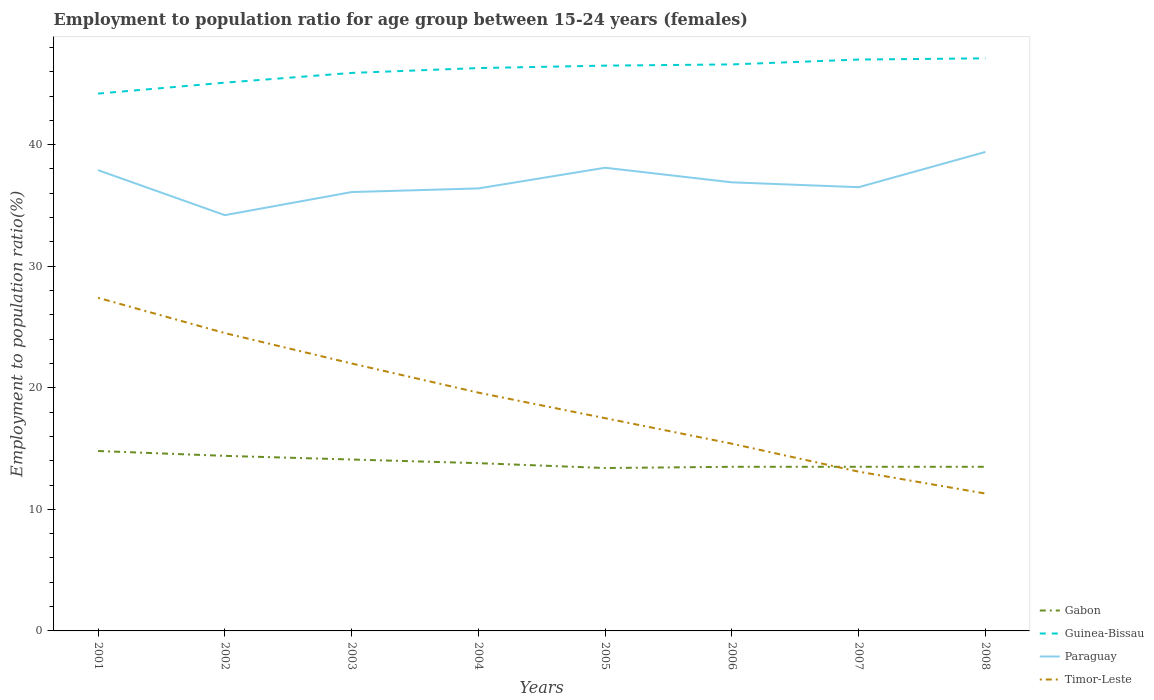Does the line corresponding to Guinea-Bissau intersect with the line corresponding to Timor-Leste?
Provide a succinct answer. No. Is the number of lines equal to the number of legend labels?
Offer a very short reply. Yes. Across all years, what is the maximum employment to population ratio in Timor-Leste?
Your answer should be very brief. 11.3. In which year was the employment to population ratio in Guinea-Bissau maximum?
Give a very brief answer. 2001. What is the total employment to population ratio in Paraguay in the graph?
Your answer should be very brief. -0.3. What is the difference between the highest and the second highest employment to population ratio in Gabon?
Offer a very short reply. 1.4. What is the difference between the highest and the lowest employment to population ratio in Gabon?
Make the answer very short. 3. Is the employment to population ratio in Guinea-Bissau strictly greater than the employment to population ratio in Paraguay over the years?
Your answer should be very brief. No. How many lines are there?
Provide a short and direct response. 4. How many years are there in the graph?
Your answer should be compact. 8. What is the difference between two consecutive major ticks on the Y-axis?
Your answer should be compact. 10. Are the values on the major ticks of Y-axis written in scientific E-notation?
Provide a short and direct response. No. Does the graph contain grids?
Make the answer very short. No. Where does the legend appear in the graph?
Offer a terse response. Bottom right. How many legend labels are there?
Your answer should be compact. 4. How are the legend labels stacked?
Make the answer very short. Vertical. What is the title of the graph?
Give a very brief answer. Employment to population ratio for age group between 15-24 years (females). What is the label or title of the X-axis?
Give a very brief answer. Years. What is the label or title of the Y-axis?
Provide a short and direct response. Employment to population ratio(%). What is the Employment to population ratio(%) in Gabon in 2001?
Your answer should be compact. 14.8. What is the Employment to population ratio(%) in Guinea-Bissau in 2001?
Ensure brevity in your answer.  44.2. What is the Employment to population ratio(%) of Paraguay in 2001?
Offer a very short reply. 37.9. What is the Employment to population ratio(%) in Timor-Leste in 2001?
Keep it short and to the point. 27.4. What is the Employment to population ratio(%) of Gabon in 2002?
Provide a short and direct response. 14.4. What is the Employment to population ratio(%) in Guinea-Bissau in 2002?
Give a very brief answer. 45.1. What is the Employment to population ratio(%) in Paraguay in 2002?
Your response must be concise. 34.2. What is the Employment to population ratio(%) in Timor-Leste in 2002?
Keep it short and to the point. 24.5. What is the Employment to population ratio(%) in Gabon in 2003?
Your answer should be very brief. 14.1. What is the Employment to population ratio(%) in Guinea-Bissau in 2003?
Keep it short and to the point. 45.9. What is the Employment to population ratio(%) of Paraguay in 2003?
Provide a succinct answer. 36.1. What is the Employment to population ratio(%) in Gabon in 2004?
Your answer should be compact. 13.8. What is the Employment to population ratio(%) of Guinea-Bissau in 2004?
Make the answer very short. 46.3. What is the Employment to population ratio(%) of Paraguay in 2004?
Ensure brevity in your answer.  36.4. What is the Employment to population ratio(%) in Timor-Leste in 2004?
Offer a very short reply. 19.6. What is the Employment to population ratio(%) of Gabon in 2005?
Make the answer very short. 13.4. What is the Employment to population ratio(%) in Guinea-Bissau in 2005?
Keep it short and to the point. 46.5. What is the Employment to population ratio(%) in Paraguay in 2005?
Your response must be concise. 38.1. What is the Employment to population ratio(%) of Timor-Leste in 2005?
Offer a terse response. 17.5. What is the Employment to population ratio(%) in Gabon in 2006?
Keep it short and to the point. 13.5. What is the Employment to population ratio(%) in Guinea-Bissau in 2006?
Offer a terse response. 46.6. What is the Employment to population ratio(%) of Paraguay in 2006?
Make the answer very short. 36.9. What is the Employment to population ratio(%) of Timor-Leste in 2006?
Provide a succinct answer. 15.4. What is the Employment to population ratio(%) in Gabon in 2007?
Ensure brevity in your answer.  13.5. What is the Employment to population ratio(%) in Paraguay in 2007?
Give a very brief answer. 36.5. What is the Employment to population ratio(%) of Timor-Leste in 2007?
Provide a succinct answer. 13.1. What is the Employment to population ratio(%) in Guinea-Bissau in 2008?
Offer a terse response. 47.1. What is the Employment to population ratio(%) in Paraguay in 2008?
Give a very brief answer. 39.4. What is the Employment to population ratio(%) in Timor-Leste in 2008?
Your answer should be compact. 11.3. Across all years, what is the maximum Employment to population ratio(%) in Gabon?
Your response must be concise. 14.8. Across all years, what is the maximum Employment to population ratio(%) of Guinea-Bissau?
Make the answer very short. 47.1. Across all years, what is the maximum Employment to population ratio(%) in Paraguay?
Keep it short and to the point. 39.4. Across all years, what is the maximum Employment to population ratio(%) of Timor-Leste?
Ensure brevity in your answer.  27.4. Across all years, what is the minimum Employment to population ratio(%) of Gabon?
Provide a short and direct response. 13.4. Across all years, what is the minimum Employment to population ratio(%) in Guinea-Bissau?
Your response must be concise. 44.2. Across all years, what is the minimum Employment to population ratio(%) in Paraguay?
Your response must be concise. 34.2. Across all years, what is the minimum Employment to population ratio(%) in Timor-Leste?
Offer a terse response. 11.3. What is the total Employment to population ratio(%) in Gabon in the graph?
Keep it short and to the point. 111. What is the total Employment to population ratio(%) of Guinea-Bissau in the graph?
Make the answer very short. 368.7. What is the total Employment to population ratio(%) in Paraguay in the graph?
Keep it short and to the point. 295.5. What is the total Employment to population ratio(%) in Timor-Leste in the graph?
Your response must be concise. 150.8. What is the difference between the Employment to population ratio(%) in Paraguay in 2001 and that in 2002?
Provide a succinct answer. 3.7. What is the difference between the Employment to population ratio(%) in Timor-Leste in 2001 and that in 2002?
Offer a terse response. 2.9. What is the difference between the Employment to population ratio(%) in Guinea-Bissau in 2001 and that in 2003?
Offer a very short reply. -1.7. What is the difference between the Employment to population ratio(%) of Paraguay in 2001 and that in 2003?
Provide a succinct answer. 1.8. What is the difference between the Employment to population ratio(%) in Timor-Leste in 2001 and that in 2004?
Ensure brevity in your answer.  7.8. What is the difference between the Employment to population ratio(%) in Guinea-Bissau in 2001 and that in 2005?
Make the answer very short. -2.3. What is the difference between the Employment to population ratio(%) in Paraguay in 2001 and that in 2005?
Ensure brevity in your answer.  -0.2. What is the difference between the Employment to population ratio(%) of Timor-Leste in 2001 and that in 2005?
Offer a terse response. 9.9. What is the difference between the Employment to population ratio(%) of Gabon in 2001 and that in 2006?
Ensure brevity in your answer.  1.3. What is the difference between the Employment to population ratio(%) in Timor-Leste in 2001 and that in 2006?
Give a very brief answer. 12. What is the difference between the Employment to population ratio(%) of Timor-Leste in 2001 and that in 2007?
Your answer should be very brief. 14.3. What is the difference between the Employment to population ratio(%) of Gabon in 2001 and that in 2008?
Ensure brevity in your answer.  1.3. What is the difference between the Employment to population ratio(%) of Guinea-Bissau in 2001 and that in 2008?
Give a very brief answer. -2.9. What is the difference between the Employment to population ratio(%) in Paraguay in 2001 and that in 2008?
Your answer should be compact. -1.5. What is the difference between the Employment to population ratio(%) of Timor-Leste in 2001 and that in 2008?
Provide a succinct answer. 16.1. What is the difference between the Employment to population ratio(%) of Guinea-Bissau in 2002 and that in 2003?
Your answer should be very brief. -0.8. What is the difference between the Employment to population ratio(%) in Paraguay in 2002 and that in 2003?
Ensure brevity in your answer.  -1.9. What is the difference between the Employment to population ratio(%) of Guinea-Bissau in 2002 and that in 2004?
Offer a terse response. -1.2. What is the difference between the Employment to population ratio(%) of Paraguay in 2002 and that in 2004?
Your answer should be very brief. -2.2. What is the difference between the Employment to population ratio(%) of Timor-Leste in 2002 and that in 2004?
Give a very brief answer. 4.9. What is the difference between the Employment to population ratio(%) in Gabon in 2002 and that in 2005?
Make the answer very short. 1. What is the difference between the Employment to population ratio(%) in Guinea-Bissau in 2002 and that in 2005?
Keep it short and to the point. -1.4. What is the difference between the Employment to population ratio(%) of Paraguay in 2002 and that in 2005?
Offer a very short reply. -3.9. What is the difference between the Employment to population ratio(%) of Timor-Leste in 2002 and that in 2005?
Offer a very short reply. 7. What is the difference between the Employment to population ratio(%) of Gabon in 2002 and that in 2006?
Your answer should be compact. 0.9. What is the difference between the Employment to population ratio(%) of Guinea-Bissau in 2002 and that in 2006?
Your response must be concise. -1.5. What is the difference between the Employment to population ratio(%) in Paraguay in 2002 and that in 2006?
Ensure brevity in your answer.  -2.7. What is the difference between the Employment to population ratio(%) in Timor-Leste in 2002 and that in 2006?
Offer a very short reply. 9.1. What is the difference between the Employment to population ratio(%) in Guinea-Bissau in 2002 and that in 2008?
Your answer should be compact. -2. What is the difference between the Employment to population ratio(%) in Paraguay in 2002 and that in 2008?
Offer a terse response. -5.2. What is the difference between the Employment to population ratio(%) of Timor-Leste in 2002 and that in 2008?
Provide a succinct answer. 13.2. What is the difference between the Employment to population ratio(%) of Gabon in 2003 and that in 2006?
Offer a terse response. 0.6. What is the difference between the Employment to population ratio(%) of Paraguay in 2003 and that in 2006?
Your answer should be compact. -0.8. What is the difference between the Employment to population ratio(%) in Timor-Leste in 2003 and that in 2006?
Your answer should be very brief. 6.6. What is the difference between the Employment to population ratio(%) in Gabon in 2003 and that in 2007?
Your answer should be compact. 0.6. What is the difference between the Employment to population ratio(%) in Paraguay in 2003 and that in 2007?
Give a very brief answer. -0.4. What is the difference between the Employment to population ratio(%) in Timor-Leste in 2003 and that in 2007?
Keep it short and to the point. 8.9. What is the difference between the Employment to population ratio(%) of Gabon in 2003 and that in 2008?
Keep it short and to the point. 0.6. What is the difference between the Employment to population ratio(%) in Guinea-Bissau in 2004 and that in 2005?
Your answer should be compact. -0.2. What is the difference between the Employment to population ratio(%) of Gabon in 2004 and that in 2007?
Offer a very short reply. 0.3. What is the difference between the Employment to population ratio(%) of Paraguay in 2004 and that in 2007?
Give a very brief answer. -0.1. What is the difference between the Employment to population ratio(%) of Timor-Leste in 2004 and that in 2007?
Give a very brief answer. 6.5. What is the difference between the Employment to population ratio(%) in Paraguay in 2004 and that in 2008?
Give a very brief answer. -3. What is the difference between the Employment to population ratio(%) of Timor-Leste in 2004 and that in 2008?
Offer a very short reply. 8.3. What is the difference between the Employment to population ratio(%) of Gabon in 2005 and that in 2006?
Offer a very short reply. -0.1. What is the difference between the Employment to population ratio(%) of Guinea-Bissau in 2005 and that in 2006?
Keep it short and to the point. -0.1. What is the difference between the Employment to population ratio(%) of Guinea-Bissau in 2005 and that in 2007?
Provide a succinct answer. -0.5. What is the difference between the Employment to population ratio(%) in Paraguay in 2005 and that in 2007?
Give a very brief answer. 1.6. What is the difference between the Employment to population ratio(%) in Timor-Leste in 2005 and that in 2007?
Provide a short and direct response. 4.4. What is the difference between the Employment to population ratio(%) in Gabon in 2005 and that in 2008?
Your answer should be compact. -0.1. What is the difference between the Employment to population ratio(%) in Paraguay in 2005 and that in 2008?
Provide a short and direct response. -1.3. What is the difference between the Employment to population ratio(%) in Gabon in 2006 and that in 2007?
Keep it short and to the point. 0. What is the difference between the Employment to population ratio(%) of Gabon in 2006 and that in 2008?
Your response must be concise. 0. What is the difference between the Employment to population ratio(%) in Guinea-Bissau in 2006 and that in 2008?
Give a very brief answer. -0.5. What is the difference between the Employment to population ratio(%) of Timor-Leste in 2006 and that in 2008?
Your answer should be compact. 4.1. What is the difference between the Employment to population ratio(%) in Paraguay in 2007 and that in 2008?
Provide a succinct answer. -2.9. What is the difference between the Employment to population ratio(%) of Timor-Leste in 2007 and that in 2008?
Keep it short and to the point. 1.8. What is the difference between the Employment to population ratio(%) in Gabon in 2001 and the Employment to population ratio(%) in Guinea-Bissau in 2002?
Give a very brief answer. -30.3. What is the difference between the Employment to population ratio(%) in Gabon in 2001 and the Employment to population ratio(%) in Paraguay in 2002?
Give a very brief answer. -19.4. What is the difference between the Employment to population ratio(%) in Guinea-Bissau in 2001 and the Employment to population ratio(%) in Paraguay in 2002?
Ensure brevity in your answer.  10. What is the difference between the Employment to population ratio(%) in Gabon in 2001 and the Employment to population ratio(%) in Guinea-Bissau in 2003?
Provide a succinct answer. -31.1. What is the difference between the Employment to population ratio(%) of Gabon in 2001 and the Employment to population ratio(%) of Paraguay in 2003?
Your answer should be very brief. -21.3. What is the difference between the Employment to population ratio(%) of Gabon in 2001 and the Employment to population ratio(%) of Timor-Leste in 2003?
Your answer should be compact. -7.2. What is the difference between the Employment to population ratio(%) in Guinea-Bissau in 2001 and the Employment to population ratio(%) in Paraguay in 2003?
Make the answer very short. 8.1. What is the difference between the Employment to population ratio(%) of Gabon in 2001 and the Employment to population ratio(%) of Guinea-Bissau in 2004?
Offer a terse response. -31.5. What is the difference between the Employment to population ratio(%) of Gabon in 2001 and the Employment to population ratio(%) of Paraguay in 2004?
Your response must be concise. -21.6. What is the difference between the Employment to population ratio(%) of Guinea-Bissau in 2001 and the Employment to population ratio(%) of Paraguay in 2004?
Give a very brief answer. 7.8. What is the difference between the Employment to population ratio(%) in Guinea-Bissau in 2001 and the Employment to population ratio(%) in Timor-Leste in 2004?
Make the answer very short. 24.6. What is the difference between the Employment to population ratio(%) of Paraguay in 2001 and the Employment to population ratio(%) of Timor-Leste in 2004?
Your answer should be compact. 18.3. What is the difference between the Employment to population ratio(%) of Gabon in 2001 and the Employment to population ratio(%) of Guinea-Bissau in 2005?
Offer a very short reply. -31.7. What is the difference between the Employment to population ratio(%) of Gabon in 2001 and the Employment to population ratio(%) of Paraguay in 2005?
Offer a very short reply. -23.3. What is the difference between the Employment to population ratio(%) in Guinea-Bissau in 2001 and the Employment to population ratio(%) in Timor-Leste in 2005?
Make the answer very short. 26.7. What is the difference between the Employment to population ratio(%) in Paraguay in 2001 and the Employment to population ratio(%) in Timor-Leste in 2005?
Ensure brevity in your answer.  20.4. What is the difference between the Employment to population ratio(%) of Gabon in 2001 and the Employment to population ratio(%) of Guinea-Bissau in 2006?
Give a very brief answer. -31.8. What is the difference between the Employment to population ratio(%) of Gabon in 2001 and the Employment to population ratio(%) of Paraguay in 2006?
Your answer should be compact. -22.1. What is the difference between the Employment to population ratio(%) of Guinea-Bissau in 2001 and the Employment to population ratio(%) of Timor-Leste in 2006?
Provide a succinct answer. 28.8. What is the difference between the Employment to population ratio(%) in Gabon in 2001 and the Employment to population ratio(%) in Guinea-Bissau in 2007?
Make the answer very short. -32.2. What is the difference between the Employment to population ratio(%) in Gabon in 2001 and the Employment to population ratio(%) in Paraguay in 2007?
Your answer should be compact. -21.7. What is the difference between the Employment to population ratio(%) in Guinea-Bissau in 2001 and the Employment to population ratio(%) in Paraguay in 2007?
Your answer should be very brief. 7.7. What is the difference between the Employment to population ratio(%) in Guinea-Bissau in 2001 and the Employment to population ratio(%) in Timor-Leste in 2007?
Provide a short and direct response. 31.1. What is the difference between the Employment to population ratio(%) in Paraguay in 2001 and the Employment to population ratio(%) in Timor-Leste in 2007?
Offer a very short reply. 24.8. What is the difference between the Employment to population ratio(%) in Gabon in 2001 and the Employment to population ratio(%) in Guinea-Bissau in 2008?
Provide a succinct answer. -32.3. What is the difference between the Employment to population ratio(%) of Gabon in 2001 and the Employment to population ratio(%) of Paraguay in 2008?
Keep it short and to the point. -24.6. What is the difference between the Employment to population ratio(%) of Gabon in 2001 and the Employment to population ratio(%) of Timor-Leste in 2008?
Provide a short and direct response. 3.5. What is the difference between the Employment to population ratio(%) in Guinea-Bissau in 2001 and the Employment to population ratio(%) in Timor-Leste in 2008?
Offer a very short reply. 32.9. What is the difference between the Employment to population ratio(%) in Paraguay in 2001 and the Employment to population ratio(%) in Timor-Leste in 2008?
Ensure brevity in your answer.  26.6. What is the difference between the Employment to population ratio(%) of Gabon in 2002 and the Employment to population ratio(%) of Guinea-Bissau in 2003?
Give a very brief answer. -31.5. What is the difference between the Employment to population ratio(%) of Gabon in 2002 and the Employment to population ratio(%) of Paraguay in 2003?
Keep it short and to the point. -21.7. What is the difference between the Employment to population ratio(%) in Guinea-Bissau in 2002 and the Employment to population ratio(%) in Paraguay in 2003?
Provide a succinct answer. 9. What is the difference between the Employment to population ratio(%) in Guinea-Bissau in 2002 and the Employment to population ratio(%) in Timor-Leste in 2003?
Your response must be concise. 23.1. What is the difference between the Employment to population ratio(%) in Gabon in 2002 and the Employment to population ratio(%) in Guinea-Bissau in 2004?
Offer a very short reply. -31.9. What is the difference between the Employment to population ratio(%) in Gabon in 2002 and the Employment to population ratio(%) in Paraguay in 2004?
Give a very brief answer. -22. What is the difference between the Employment to population ratio(%) in Guinea-Bissau in 2002 and the Employment to population ratio(%) in Paraguay in 2004?
Offer a terse response. 8.7. What is the difference between the Employment to population ratio(%) of Gabon in 2002 and the Employment to population ratio(%) of Guinea-Bissau in 2005?
Offer a very short reply. -32.1. What is the difference between the Employment to population ratio(%) of Gabon in 2002 and the Employment to population ratio(%) of Paraguay in 2005?
Give a very brief answer. -23.7. What is the difference between the Employment to population ratio(%) in Gabon in 2002 and the Employment to population ratio(%) in Timor-Leste in 2005?
Keep it short and to the point. -3.1. What is the difference between the Employment to population ratio(%) in Guinea-Bissau in 2002 and the Employment to population ratio(%) in Timor-Leste in 2005?
Give a very brief answer. 27.6. What is the difference between the Employment to population ratio(%) of Paraguay in 2002 and the Employment to population ratio(%) of Timor-Leste in 2005?
Your answer should be very brief. 16.7. What is the difference between the Employment to population ratio(%) of Gabon in 2002 and the Employment to population ratio(%) of Guinea-Bissau in 2006?
Provide a short and direct response. -32.2. What is the difference between the Employment to population ratio(%) in Gabon in 2002 and the Employment to population ratio(%) in Paraguay in 2006?
Provide a succinct answer. -22.5. What is the difference between the Employment to population ratio(%) of Gabon in 2002 and the Employment to population ratio(%) of Timor-Leste in 2006?
Provide a succinct answer. -1. What is the difference between the Employment to population ratio(%) of Guinea-Bissau in 2002 and the Employment to population ratio(%) of Timor-Leste in 2006?
Your response must be concise. 29.7. What is the difference between the Employment to population ratio(%) in Gabon in 2002 and the Employment to population ratio(%) in Guinea-Bissau in 2007?
Keep it short and to the point. -32.6. What is the difference between the Employment to population ratio(%) of Gabon in 2002 and the Employment to population ratio(%) of Paraguay in 2007?
Provide a short and direct response. -22.1. What is the difference between the Employment to population ratio(%) of Paraguay in 2002 and the Employment to population ratio(%) of Timor-Leste in 2007?
Offer a terse response. 21.1. What is the difference between the Employment to population ratio(%) of Gabon in 2002 and the Employment to population ratio(%) of Guinea-Bissau in 2008?
Ensure brevity in your answer.  -32.7. What is the difference between the Employment to population ratio(%) of Gabon in 2002 and the Employment to population ratio(%) of Paraguay in 2008?
Offer a very short reply. -25. What is the difference between the Employment to population ratio(%) in Gabon in 2002 and the Employment to population ratio(%) in Timor-Leste in 2008?
Ensure brevity in your answer.  3.1. What is the difference between the Employment to population ratio(%) of Guinea-Bissau in 2002 and the Employment to population ratio(%) of Timor-Leste in 2008?
Keep it short and to the point. 33.8. What is the difference between the Employment to population ratio(%) in Paraguay in 2002 and the Employment to population ratio(%) in Timor-Leste in 2008?
Provide a short and direct response. 22.9. What is the difference between the Employment to population ratio(%) in Gabon in 2003 and the Employment to population ratio(%) in Guinea-Bissau in 2004?
Provide a short and direct response. -32.2. What is the difference between the Employment to population ratio(%) in Gabon in 2003 and the Employment to population ratio(%) in Paraguay in 2004?
Offer a terse response. -22.3. What is the difference between the Employment to population ratio(%) in Gabon in 2003 and the Employment to population ratio(%) in Timor-Leste in 2004?
Ensure brevity in your answer.  -5.5. What is the difference between the Employment to population ratio(%) in Guinea-Bissau in 2003 and the Employment to population ratio(%) in Timor-Leste in 2004?
Your response must be concise. 26.3. What is the difference between the Employment to population ratio(%) in Gabon in 2003 and the Employment to population ratio(%) in Guinea-Bissau in 2005?
Ensure brevity in your answer.  -32.4. What is the difference between the Employment to population ratio(%) of Gabon in 2003 and the Employment to population ratio(%) of Paraguay in 2005?
Provide a succinct answer. -24. What is the difference between the Employment to population ratio(%) of Gabon in 2003 and the Employment to population ratio(%) of Timor-Leste in 2005?
Offer a very short reply. -3.4. What is the difference between the Employment to population ratio(%) in Guinea-Bissau in 2003 and the Employment to population ratio(%) in Timor-Leste in 2005?
Provide a short and direct response. 28.4. What is the difference between the Employment to population ratio(%) of Gabon in 2003 and the Employment to population ratio(%) of Guinea-Bissau in 2006?
Your response must be concise. -32.5. What is the difference between the Employment to population ratio(%) in Gabon in 2003 and the Employment to population ratio(%) in Paraguay in 2006?
Keep it short and to the point. -22.8. What is the difference between the Employment to population ratio(%) of Guinea-Bissau in 2003 and the Employment to population ratio(%) of Paraguay in 2006?
Make the answer very short. 9. What is the difference between the Employment to population ratio(%) of Guinea-Bissau in 2003 and the Employment to population ratio(%) of Timor-Leste in 2006?
Ensure brevity in your answer.  30.5. What is the difference between the Employment to population ratio(%) in Paraguay in 2003 and the Employment to population ratio(%) in Timor-Leste in 2006?
Your response must be concise. 20.7. What is the difference between the Employment to population ratio(%) in Gabon in 2003 and the Employment to population ratio(%) in Guinea-Bissau in 2007?
Make the answer very short. -32.9. What is the difference between the Employment to population ratio(%) in Gabon in 2003 and the Employment to population ratio(%) in Paraguay in 2007?
Give a very brief answer. -22.4. What is the difference between the Employment to population ratio(%) of Guinea-Bissau in 2003 and the Employment to population ratio(%) of Timor-Leste in 2007?
Provide a succinct answer. 32.8. What is the difference between the Employment to population ratio(%) of Gabon in 2003 and the Employment to population ratio(%) of Guinea-Bissau in 2008?
Ensure brevity in your answer.  -33. What is the difference between the Employment to population ratio(%) in Gabon in 2003 and the Employment to population ratio(%) in Paraguay in 2008?
Your response must be concise. -25.3. What is the difference between the Employment to population ratio(%) of Guinea-Bissau in 2003 and the Employment to population ratio(%) of Paraguay in 2008?
Offer a terse response. 6.5. What is the difference between the Employment to population ratio(%) of Guinea-Bissau in 2003 and the Employment to population ratio(%) of Timor-Leste in 2008?
Offer a very short reply. 34.6. What is the difference between the Employment to population ratio(%) of Paraguay in 2003 and the Employment to population ratio(%) of Timor-Leste in 2008?
Offer a very short reply. 24.8. What is the difference between the Employment to population ratio(%) in Gabon in 2004 and the Employment to population ratio(%) in Guinea-Bissau in 2005?
Your response must be concise. -32.7. What is the difference between the Employment to population ratio(%) of Gabon in 2004 and the Employment to population ratio(%) of Paraguay in 2005?
Offer a very short reply. -24.3. What is the difference between the Employment to population ratio(%) in Guinea-Bissau in 2004 and the Employment to population ratio(%) in Timor-Leste in 2005?
Give a very brief answer. 28.8. What is the difference between the Employment to population ratio(%) of Gabon in 2004 and the Employment to population ratio(%) of Guinea-Bissau in 2006?
Provide a succinct answer. -32.8. What is the difference between the Employment to population ratio(%) of Gabon in 2004 and the Employment to population ratio(%) of Paraguay in 2006?
Ensure brevity in your answer.  -23.1. What is the difference between the Employment to population ratio(%) in Gabon in 2004 and the Employment to population ratio(%) in Timor-Leste in 2006?
Your answer should be compact. -1.6. What is the difference between the Employment to population ratio(%) of Guinea-Bissau in 2004 and the Employment to population ratio(%) of Paraguay in 2006?
Your answer should be very brief. 9.4. What is the difference between the Employment to population ratio(%) of Guinea-Bissau in 2004 and the Employment to population ratio(%) of Timor-Leste in 2006?
Provide a short and direct response. 30.9. What is the difference between the Employment to population ratio(%) of Paraguay in 2004 and the Employment to population ratio(%) of Timor-Leste in 2006?
Your answer should be compact. 21. What is the difference between the Employment to population ratio(%) in Gabon in 2004 and the Employment to population ratio(%) in Guinea-Bissau in 2007?
Keep it short and to the point. -33.2. What is the difference between the Employment to population ratio(%) in Gabon in 2004 and the Employment to population ratio(%) in Paraguay in 2007?
Offer a terse response. -22.7. What is the difference between the Employment to population ratio(%) of Guinea-Bissau in 2004 and the Employment to population ratio(%) of Timor-Leste in 2007?
Offer a very short reply. 33.2. What is the difference between the Employment to population ratio(%) in Paraguay in 2004 and the Employment to population ratio(%) in Timor-Leste in 2007?
Offer a very short reply. 23.3. What is the difference between the Employment to population ratio(%) of Gabon in 2004 and the Employment to population ratio(%) of Guinea-Bissau in 2008?
Your answer should be very brief. -33.3. What is the difference between the Employment to population ratio(%) in Gabon in 2004 and the Employment to population ratio(%) in Paraguay in 2008?
Offer a very short reply. -25.6. What is the difference between the Employment to population ratio(%) in Guinea-Bissau in 2004 and the Employment to population ratio(%) in Paraguay in 2008?
Provide a short and direct response. 6.9. What is the difference between the Employment to population ratio(%) of Guinea-Bissau in 2004 and the Employment to population ratio(%) of Timor-Leste in 2008?
Give a very brief answer. 35. What is the difference between the Employment to population ratio(%) of Paraguay in 2004 and the Employment to population ratio(%) of Timor-Leste in 2008?
Give a very brief answer. 25.1. What is the difference between the Employment to population ratio(%) in Gabon in 2005 and the Employment to population ratio(%) in Guinea-Bissau in 2006?
Ensure brevity in your answer.  -33.2. What is the difference between the Employment to population ratio(%) of Gabon in 2005 and the Employment to population ratio(%) of Paraguay in 2006?
Give a very brief answer. -23.5. What is the difference between the Employment to population ratio(%) in Gabon in 2005 and the Employment to population ratio(%) in Timor-Leste in 2006?
Keep it short and to the point. -2. What is the difference between the Employment to population ratio(%) in Guinea-Bissau in 2005 and the Employment to population ratio(%) in Timor-Leste in 2006?
Offer a very short reply. 31.1. What is the difference between the Employment to population ratio(%) of Paraguay in 2005 and the Employment to population ratio(%) of Timor-Leste in 2006?
Offer a terse response. 22.7. What is the difference between the Employment to population ratio(%) of Gabon in 2005 and the Employment to population ratio(%) of Guinea-Bissau in 2007?
Ensure brevity in your answer.  -33.6. What is the difference between the Employment to population ratio(%) of Gabon in 2005 and the Employment to population ratio(%) of Paraguay in 2007?
Give a very brief answer. -23.1. What is the difference between the Employment to population ratio(%) in Gabon in 2005 and the Employment to population ratio(%) in Timor-Leste in 2007?
Offer a terse response. 0.3. What is the difference between the Employment to population ratio(%) of Guinea-Bissau in 2005 and the Employment to population ratio(%) of Timor-Leste in 2007?
Offer a terse response. 33.4. What is the difference between the Employment to population ratio(%) of Gabon in 2005 and the Employment to population ratio(%) of Guinea-Bissau in 2008?
Keep it short and to the point. -33.7. What is the difference between the Employment to population ratio(%) of Gabon in 2005 and the Employment to population ratio(%) of Paraguay in 2008?
Ensure brevity in your answer.  -26. What is the difference between the Employment to population ratio(%) in Gabon in 2005 and the Employment to population ratio(%) in Timor-Leste in 2008?
Provide a short and direct response. 2.1. What is the difference between the Employment to population ratio(%) in Guinea-Bissau in 2005 and the Employment to population ratio(%) in Timor-Leste in 2008?
Your response must be concise. 35.2. What is the difference between the Employment to population ratio(%) of Paraguay in 2005 and the Employment to population ratio(%) of Timor-Leste in 2008?
Give a very brief answer. 26.8. What is the difference between the Employment to population ratio(%) of Gabon in 2006 and the Employment to population ratio(%) of Guinea-Bissau in 2007?
Your answer should be compact. -33.5. What is the difference between the Employment to population ratio(%) in Gabon in 2006 and the Employment to population ratio(%) in Paraguay in 2007?
Provide a short and direct response. -23. What is the difference between the Employment to population ratio(%) of Gabon in 2006 and the Employment to population ratio(%) of Timor-Leste in 2007?
Your answer should be compact. 0.4. What is the difference between the Employment to population ratio(%) in Guinea-Bissau in 2006 and the Employment to population ratio(%) in Timor-Leste in 2007?
Offer a terse response. 33.5. What is the difference between the Employment to population ratio(%) of Paraguay in 2006 and the Employment to population ratio(%) of Timor-Leste in 2007?
Give a very brief answer. 23.8. What is the difference between the Employment to population ratio(%) of Gabon in 2006 and the Employment to population ratio(%) of Guinea-Bissau in 2008?
Give a very brief answer. -33.6. What is the difference between the Employment to population ratio(%) in Gabon in 2006 and the Employment to population ratio(%) in Paraguay in 2008?
Make the answer very short. -25.9. What is the difference between the Employment to population ratio(%) of Gabon in 2006 and the Employment to population ratio(%) of Timor-Leste in 2008?
Your answer should be very brief. 2.2. What is the difference between the Employment to population ratio(%) in Guinea-Bissau in 2006 and the Employment to population ratio(%) in Timor-Leste in 2008?
Your answer should be compact. 35.3. What is the difference between the Employment to population ratio(%) of Paraguay in 2006 and the Employment to population ratio(%) of Timor-Leste in 2008?
Provide a succinct answer. 25.6. What is the difference between the Employment to population ratio(%) in Gabon in 2007 and the Employment to population ratio(%) in Guinea-Bissau in 2008?
Your answer should be very brief. -33.6. What is the difference between the Employment to population ratio(%) of Gabon in 2007 and the Employment to population ratio(%) of Paraguay in 2008?
Your response must be concise. -25.9. What is the difference between the Employment to population ratio(%) in Gabon in 2007 and the Employment to population ratio(%) in Timor-Leste in 2008?
Give a very brief answer. 2.2. What is the difference between the Employment to population ratio(%) of Guinea-Bissau in 2007 and the Employment to population ratio(%) of Timor-Leste in 2008?
Keep it short and to the point. 35.7. What is the difference between the Employment to population ratio(%) of Paraguay in 2007 and the Employment to population ratio(%) of Timor-Leste in 2008?
Keep it short and to the point. 25.2. What is the average Employment to population ratio(%) in Gabon per year?
Your response must be concise. 13.88. What is the average Employment to population ratio(%) of Guinea-Bissau per year?
Provide a succinct answer. 46.09. What is the average Employment to population ratio(%) in Paraguay per year?
Your answer should be very brief. 36.94. What is the average Employment to population ratio(%) of Timor-Leste per year?
Provide a short and direct response. 18.85. In the year 2001, what is the difference between the Employment to population ratio(%) of Gabon and Employment to population ratio(%) of Guinea-Bissau?
Provide a short and direct response. -29.4. In the year 2001, what is the difference between the Employment to population ratio(%) of Gabon and Employment to population ratio(%) of Paraguay?
Your answer should be very brief. -23.1. In the year 2001, what is the difference between the Employment to population ratio(%) in Paraguay and Employment to population ratio(%) in Timor-Leste?
Offer a very short reply. 10.5. In the year 2002, what is the difference between the Employment to population ratio(%) in Gabon and Employment to population ratio(%) in Guinea-Bissau?
Ensure brevity in your answer.  -30.7. In the year 2002, what is the difference between the Employment to population ratio(%) in Gabon and Employment to population ratio(%) in Paraguay?
Offer a very short reply. -19.8. In the year 2002, what is the difference between the Employment to population ratio(%) of Guinea-Bissau and Employment to population ratio(%) of Paraguay?
Offer a terse response. 10.9. In the year 2002, what is the difference between the Employment to population ratio(%) of Guinea-Bissau and Employment to population ratio(%) of Timor-Leste?
Give a very brief answer. 20.6. In the year 2002, what is the difference between the Employment to population ratio(%) in Paraguay and Employment to population ratio(%) in Timor-Leste?
Your response must be concise. 9.7. In the year 2003, what is the difference between the Employment to population ratio(%) of Gabon and Employment to population ratio(%) of Guinea-Bissau?
Ensure brevity in your answer.  -31.8. In the year 2003, what is the difference between the Employment to population ratio(%) in Gabon and Employment to population ratio(%) in Timor-Leste?
Offer a very short reply. -7.9. In the year 2003, what is the difference between the Employment to population ratio(%) of Guinea-Bissau and Employment to population ratio(%) of Paraguay?
Offer a very short reply. 9.8. In the year 2003, what is the difference between the Employment to population ratio(%) of Guinea-Bissau and Employment to population ratio(%) of Timor-Leste?
Provide a succinct answer. 23.9. In the year 2003, what is the difference between the Employment to population ratio(%) in Paraguay and Employment to population ratio(%) in Timor-Leste?
Your answer should be compact. 14.1. In the year 2004, what is the difference between the Employment to population ratio(%) of Gabon and Employment to population ratio(%) of Guinea-Bissau?
Offer a very short reply. -32.5. In the year 2004, what is the difference between the Employment to population ratio(%) of Gabon and Employment to population ratio(%) of Paraguay?
Give a very brief answer. -22.6. In the year 2004, what is the difference between the Employment to population ratio(%) in Gabon and Employment to population ratio(%) in Timor-Leste?
Make the answer very short. -5.8. In the year 2004, what is the difference between the Employment to population ratio(%) of Guinea-Bissau and Employment to population ratio(%) of Timor-Leste?
Keep it short and to the point. 26.7. In the year 2004, what is the difference between the Employment to population ratio(%) in Paraguay and Employment to population ratio(%) in Timor-Leste?
Provide a succinct answer. 16.8. In the year 2005, what is the difference between the Employment to population ratio(%) of Gabon and Employment to population ratio(%) of Guinea-Bissau?
Make the answer very short. -33.1. In the year 2005, what is the difference between the Employment to population ratio(%) of Gabon and Employment to population ratio(%) of Paraguay?
Give a very brief answer. -24.7. In the year 2005, what is the difference between the Employment to population ratio(%) in Paraguay and Employment to population ratio(%) in Timor-Leste?
Keep it short and to the point. 20.6. In the year 2006, what is the difference between the Employment to population ratio(%) in Gabon and Employment to population ratio(%) in Guinea-Bissau?
Make the answer very short. -33.1. In the year 2006, what is the difference between the Employment to population ratio(%) in Gabon and Employment to population ratio(%) in Paraguay?
Your response must be concise. -23.4. In the year 2006, what is the difference between the Employment to population ratio(%) in Gabon and Employment to population ratio(%) in Timor-Leste?
Your answer should be very brief. -1.9. In the year 2006, what is the difference between the Employment to population ratio(%) in Guinea-Bissau and Employment to population ratio(%) in Paraguay?
Your response must be concise. 9.7. In the year 2006, what is the difference between the Employment to population ratio(%) of Guinea-Bissau and Employment to population ratio(%) of Timor-Leste?
Offer a very short reply. 31.2. In the year 2006, what is the difference between the Employment to population ratio(%) in Paraguay and Employment to population ratio(%) in Timor-Leste?
Give a very brief answer. 21.5. In the year 2007, what is the difference between the Employment to population ratio(%) of Gabon and Employment to population ratio(%) of Guinea-Bissau?
Make the answer very short. -33.5. In the year 2007, what is the difference between the Employment to population ratio(%) in Gabon and Employment to population ratio(%) in Paraguay?
Your response must be concise. -23. In the year 2007, what is the difference between the Employment to population ratio(%) of Gabon and Employment to population ratio(%) of Timor-Leste?
Your response must be concise. 0.4. In the year 2007, what is the difference between the Employment to population ratio(%) of Guinea-Bissau and Employment to population ratio(%) of Paraguay?
Offer a very short reply. 10.5. In the year 2007, what is the difference between the Employment to population ratio(%) in Guinea-Bissau and Employment to population ratio(%) in Timor-Leste?
Your response must be concise. 33.9. In the year 2007, what is the difference between the Employment to population ratio(%) of Paraguay and Employment to population ratio(%) of Timor-Leste?
Offer a very short reply. 23.4. In the year 2008, what is the difference between the Employment to population ratio(%) in Gabon and Employment to population ratio(%) in Guinea-Bissau?
Your answer should be compact. -33.6. In the year 2008, what is the difference between the Employment to population ratio(%) of Gabon and Employment to population ratio(%) of Paraguay?
Provide a succinct answer. -25.9. In the year 2008, what is the difference between the Employment to population ratio(%) of Guinea-Bissau and Employment to population ratio(%) of Timor-Leste?
Give a very brief answer. 35.8. In the year 2008, what is the difference between the Employment to population ratio(%) in Paraguay and Employment to population ratio(%) in Timor-Leste?
Give a very brief answer. 28.1. What is the ratio of the Employment to population ratio(%) in Gabon in 2001 to that in 2002?
Your response must be concise. 1.03. What is the ratio of the Employment to population ratio(%) of Guinea-Bissau in 2001 to that in 2002?
Ensure brevity in your answer.  0.98. What is the ratio of the Employment to population ratio(%) in Paraguay in 2001 to that in 2002?
Ensure brevity in your answer.  1.11. What is the ratio of the Employment to population ratio(%) in Timor-Leste in 2001 to that in 2002?
Offer a terse response. 1.12. What is the ratio of the Employment to population ratio(%) of Gabon in 2001 to that in 2003?
Your answer should be very brief. 1.05. What is the ratio of the Employment to population ratio(%) of Paraguay in 2001 to that in 2003?
Offer a terse response. 1.05. What is the ratio of the Employment to population ratio(%) in Timor-Leste in 2001 to that in 2003?
Give a very brief answer. 1.25. What is the ratio of the Employment to population ratio(%) in Gabon in 2001 to that in 2004?
Your answer should be compact. 1.07. What is the ratio of the Employment to population ratio(%) of Guinea-Bissau in 2001 to that in 2004?
Offer a terse response. 0.95. What is the ratio of the Employment to population ratio(%) in Paraguay in 2001 to that in 2004?
Your answer should be compact. 1.04. What is the ratio of the Employment to population ratio(%) of Timor-Leste in 2001 to that in 2004?
Give a very brief answer. 1.4. What is the ratio of the Employment to population ratio(%) in Gabon in 2001 to that in 2005?
Provide a succinct answer. 1.1. What is the ratio of the Employment to population ratio(%) of Guinea-Bissau in 2001 to that in 2005?
Offer a very short reply. 0.95. What is the ratio of the Employment to population ratio(%) in Paraguay in 2001 to that in 2005?
Provide a short and direct response. 0.99. What is the ratio of the Employment to population ratio(%) in Timor-Leste in 2001 to that in 2005?
Provide a short and direct response. 1.57. What is the ratio of the Employment to population ratio(%) of Gabon in 2001 to that in 2006?
Keep it short and to the point. 1.1. What is the ratio of the Employment to population ratio(%) in Guinea-Bissau in 2001 to that in 2006?
Your answer should be compact. 0.95. What is the ratio of the Employment to population ratio(%) in Paraguay in 2001 to that in 2006?
Ensure brevity in your answer.  1.03. What is the ratio of the Employment to population ratio(%) in Timor-Leste in 2001 to that in 2006?
Your response must be concise. 1.78. What is the ratio of the Employment to population ratio(%) of Gabon in 2001 to that in 2007?
Your response must be concise. 1.1. What is the ratio of the Employment to population ratio(%) in Guinea-Bissau in 2001 to that in 2007?
Keep it short and to the point. 0.94. What is the ratio of the Employment to population ratio(%) of Paraguay in 2001 to that in 2007?
Provide a succinct answer. 1.04. What is the ratio of the Employment to population ratio(%) in Timor-Leste in 2001 to that in 2007?
Provide a succinct answer. 2.09. What is the ratio of the Employment to population ratio(%) of Gabon in 2001 to that in 2008?
Provide a succinct answer. 1.1. What is the ratio of the Employment to population ratio(%) of Guinea-Bissau in 2001 to that in 2008?
Your answer should be very brief. 0.94. What is the ratio of the Employment to population ratio(%) in Paraguay in 2001 to that in 2008?
Offer a very short reply. 0.96. What is the ratio of the Employment to population ratio(%) in Timor-Leste in 2001 to that in 2008?
Provide a succinct answer. 2.42. What is the ratio of the Employment to population ratio(%) in Gabon in 2002 to that in 2003?
Give a very brief answer. 1.02. What is the ratio of the Employment to population ratio(%) in Guinea-Bissau in 2002 to that in 2003?
Your response must be concise. 0.98. What is the ratio of the Employment to population ratio(%) of Timor-Leste in 2002 to that in 2003?
Give a very brief answer. 1.11. What is the ratio of the Employment to population ratio(%) in Gabon in 2002 to that in 2004?
Keep it short and to the point. 1.04. What is the ratio of the Employment to population ratio(%) in Guinea-Bissau in 2002 to that in 2004?
Your answer should be very brief. 0.97. What is the ratio of the Employment to population ratio(%) in Paraguay in 2002 to that in 2004?
Provide a short and direct response. 0.94. What is the ratio of the Employment to population ratio(%) of Gabon in 2002 to that in 2005?
Your answer should be very brief. 1.07. What is the ratio of the Employment to population ratio(%) of Guinea-Bissau in 2002 to that in 2005?
Offer a very short reply. 0.97. What is the ratio of the Employment to population ratio(%) of Paraguay in 2002 to that in 2005?
Keep it short and to the point. 0.9. What is the ratio of the Employment to population ratio(%) in Timor-Leste in 2002 to that in 2005?
Give a very brief answer. 1.4. What is the ratio of the Employment to population ratio(%) of Gabon in 2002 to that in 2006?
Your answer should be compact. 1.07. What is the ratio of the Employment to population ratio(%) in Guinea-Bissau in 2002 to that in 2006?
Your answer should be compact. 0.97. What is the ratio of the Employment to population ratio(%) in Paraguay in 2002 to that in 2006?
Give a very brief answer. 0.93. What is the ratio of the Employment to population ratio(%) in Timor-Leste in 2002 to that in 2006?
Keep it short and to the point. 1.59. What is the ratio of the Employment to population ratio(%) in Gabon in 2002 to that in 2007?
Keep it short and to the point. 1.07. What is the ratio of the Employment to population ratio(%) in Guinea-Bissau in 2002 to that in 2007?
Your response must be concise. 0.96. What is the ratio of the Employment to population ratio(%) in Paraguay in 2002 to that in 2007?
Offer a terse response. 0.94. What is the ratio of the Employment to population ratio(%) of Timor-Leste in 2002 to that in 2007?
Your answer should be compact. 1.87. What is the ratio of the Employment to population ratio(%) of Gabon in 2002 to that in 2008?
Give a very brief answer. 1.07. What is the ratio of the Employment to population ratio(%) in Guinea-Bissau in 2002 to that in 2008?
Your response must be concise. 0.96. What is the ratio of the Employment to population ratio(%) of Paraguay in 2002 to that in 2008?
Give a very brief answer. 0.87. What is the ratio of the Employment to population ratio(%) in Timor-Leste in 2002 to that in 2008?
Keep it short and to the point. 2.17. What is the ratio of the Employment to population ratio(%) of Gabon in 2003 to that in 2004?
Offer a very short reply. 1.02. What is the ratio of the Employment to population ratio(%) of Guinea-Bissau in 2003 to that in 2004?
Ensure brevity in your answer.  0.99. What is the ratio of the Employment to population ratio(%) of Paraguay in 2003 to that in 2004?
Your answer should be very brief. 0.99. What is the ratio of the Employment to population ratio(%) of Timor-Leste in 2003 to that in 2004?
Offer a terse response. 1.12. What is the ratio of the Employment to population ratio(%) of Gabon in 2003 to that in 2005?
Your response must be concise. 1.05. What is the ratio of the Employment to population ratio(%) of Guinea-Bissau in 2003 to that in 2005?
Offer a very short reply. 0.99. What is the ratio of the Employment to population ratio(%) of Paraguay in 2003 to that in 2005?
Ensure brevity in your answer.  0.95. What is the ratio of the Employment to population ratio(%) of Timor-Leste in 2003 to that in 2005?
Offer a terse response. 1.26. What is the ratio of the Employment to population ratio(%) of Gabon in 2003 to that in 2006?
Offer a terse response. 1.04. What is the ratio of the Employment to population ratio(%) in Guinea-Bissau in 2003 to that in 2006?
Provide a short and direct response. 0.98. What is the ratio of the Employment to population ratio(%) of Paraguay in 2003 to that in 2006?
Ensure brevity in your answer.  0.98. What is the ratio of the Employment to population ratio(%) of Timor-Leste in 2003 to that in 2006?
Make the answer very short. 1.43. What is the ratio of the Employment to population ratio(%) in Gabon in 2003 to that in 2007?
Your answer should be very brief. 1.04. What is the ratio of the Employment to population ratio(%) in Guinea-Bissau in 2003 to that in 2007?
Your answer should be very brief. 0.98. What is the ratio of the Employment to population ratio(%) of Paraguay in 2003 to that in 2007?
Your answer should be very brief. 0.99. What is the ratio of the Employment to population ratio(%) in Timor-Leste in 2003 to that in 2007?
Your response must be concise. 1.68. What is the ratio of the Employment to population ratio(%) of Gabon in 2003 to that in 2008?
Your answer should be compact. 1.04. What is the ratio of the Employment to population ratio(%) in Guinea-Bissau in 2003 to that in 2008?
Provide a succinct answer. 0.97. What is the ratio of the Employment to population ratio(%) of Paraguay in 2003 to that in 2008?
Provide a short and direct response. 0.92. What is the ratio of the Employment to population ratio(%) of Timor-Leste in 2003 to that in 2008?
Offer a terse response. 1.95. What is the ratio of the Employment to population ratio(%) in Gabon in 2004 to that in 2005?
Your answer should be compact. 1.03. What is the ratio of the Employment to population ratio(%) of Paraguay in 2004 to that in 2005?
Your answer should be very brief. 0.96. What is the ratio of the Employment to population ratio(%) in Timor-Leste in 2004 to that in 2005?
Keep it short and to the point. 1.12. What is the ratio of the Employment to population ratio(%) of Gabon in 2004 to that in 2006?
Your answer should be very brief. 1.02. What is the ratio of the Employment to population ratio(%) in Paraguay in 2004 to that in 2006?
Ensure brevity in your answer.  0.99. What is the ratio of the Employment to population ratio(%) of Timor-Leste in 2004 to that in 2006?
Make the answer very short. 1.27. What is the ratio of the Employment to population ratio(%) of Gabon in 2004 to that in 2007?
Make the answer very short. 1.02. What is the ratio of the Employment to population ratio(%) of Guinea-Bissau in 2004 to that in 2007?
Your response must be concise. 0.99. What is the ratio of the Employment to population ratio(%) in Paraguay in 2004 to that in 2007?
Offer a very short reply. 1. What is the ratio of the Employment to population ratio(%) in Timor-Leste in 2004 to that in 2007?
Your answer should be very brief. 1.5. What is the ratio of the Employment to population ratio(%) in Gabon in 2004 to that in 2008?
Your response must be concise. 1.02. What is the ratio of the Employment to population ratio(%) of Guinea-Bissau in 2004 to that in 2008?
Your answer should be very brief. 0.98. What is the ratio of the Employment to population ratio(%) in Paraguay in 2004 to that in 2008?
Give a very brief answer. 0.92. What is the ratio of the Employment to population ratio(%) of Timor-Leste in 2004 to that in 2008?
Your response must be concise. 1.73. What is the ratio of the Employment to population ratio(%) of Paraguay in 2005 to that in 2006?
Offer a terse response. 1.03. What is the ratio of the Employment to population ratio(%) in Timor-Leste in 2005 to that in 2006?
Ensure brevity in your answer.  1.14. What is the ratio of the Employment to population ratio(%) of Guinea-Bissau in 2005 to that in 2007?
Your response must be concise. 0.99. What is the ratio of the Employment to population ratio(%) in Paraguay in 2005 to that in 2007?
Provide a succinct answer. 1.04. What is the ratio of the Employment to population ratio(%) of Timor-Leste in 2005 to that in 2007?
Offer a terse response. 1.34. What is the ratio of the Employment to population ratio(%) of Gabon in 2005 to that in 2008?
Offer a terse response. 0.99. What is the ratio of the Employment to population ratio(%) in Guinea-Bissau in 2005 to that in 2008?
Provide a succinct answer. 0.99. What is the ratio of the Employment to population ratio(%) in Paraguay in 2005 to that in 2008?
Ensure brevity in your answer.  0.97. What is the ratio of the Employment to population ratio(%) in Timor-Leste in 2005 to that in 2008?
Offer a very short reply. 1.55. What is the ratio of the Employment to population ratio(%) in Guinea-Bissau in 2006 to that in 2007?
Make the answer very short. 0.99. What is the ratio of the Employment to population ratio(%) of Timor-Leste in 2006 to that in 2007?
Provide a short and direct response. 1.18. What is the ratio of the Employment to population ratio(%) in Gabon in 2006 to that in 2008?
Your answer should be very brief. 1. What is the ratio of the Employment to population ratio(%) in Paraguay in 2006 to that in 2008?
Your answer should be very brief. 0.94. What is the ratio of the Employment to population ratio(%) in Timor-Leste in 2006 to that in 2008?
Your answer should be very brief. 1.36. What is the ratio of the Employment to population ratio(%) of Gabon in 2007 to that in 2008?
Make the answer very short. 1. What is the ratio of the Employment to population ratio(%) of Paraguay in 2007 to that in 2008?
Offer a terse response. 0.93. What is the ratio of the Employment to population ratio(%) of Timor-Leste in 2007 to that in 2008?
Your response must be concise. 1.16. What is the difference between the highest and the second highest Employment to population ratio(%) of Gabon?
Offer a terse response. 0.4. What is the difference between the highest and the second highest Employment to population ratio(%) of Timor-Leste?
Your answer should be very brief. 2.9. What is the difference between the highest and the lowest Employment to population ratio(%) in Timor-Leste?
Offer a terse response. 16.1. 